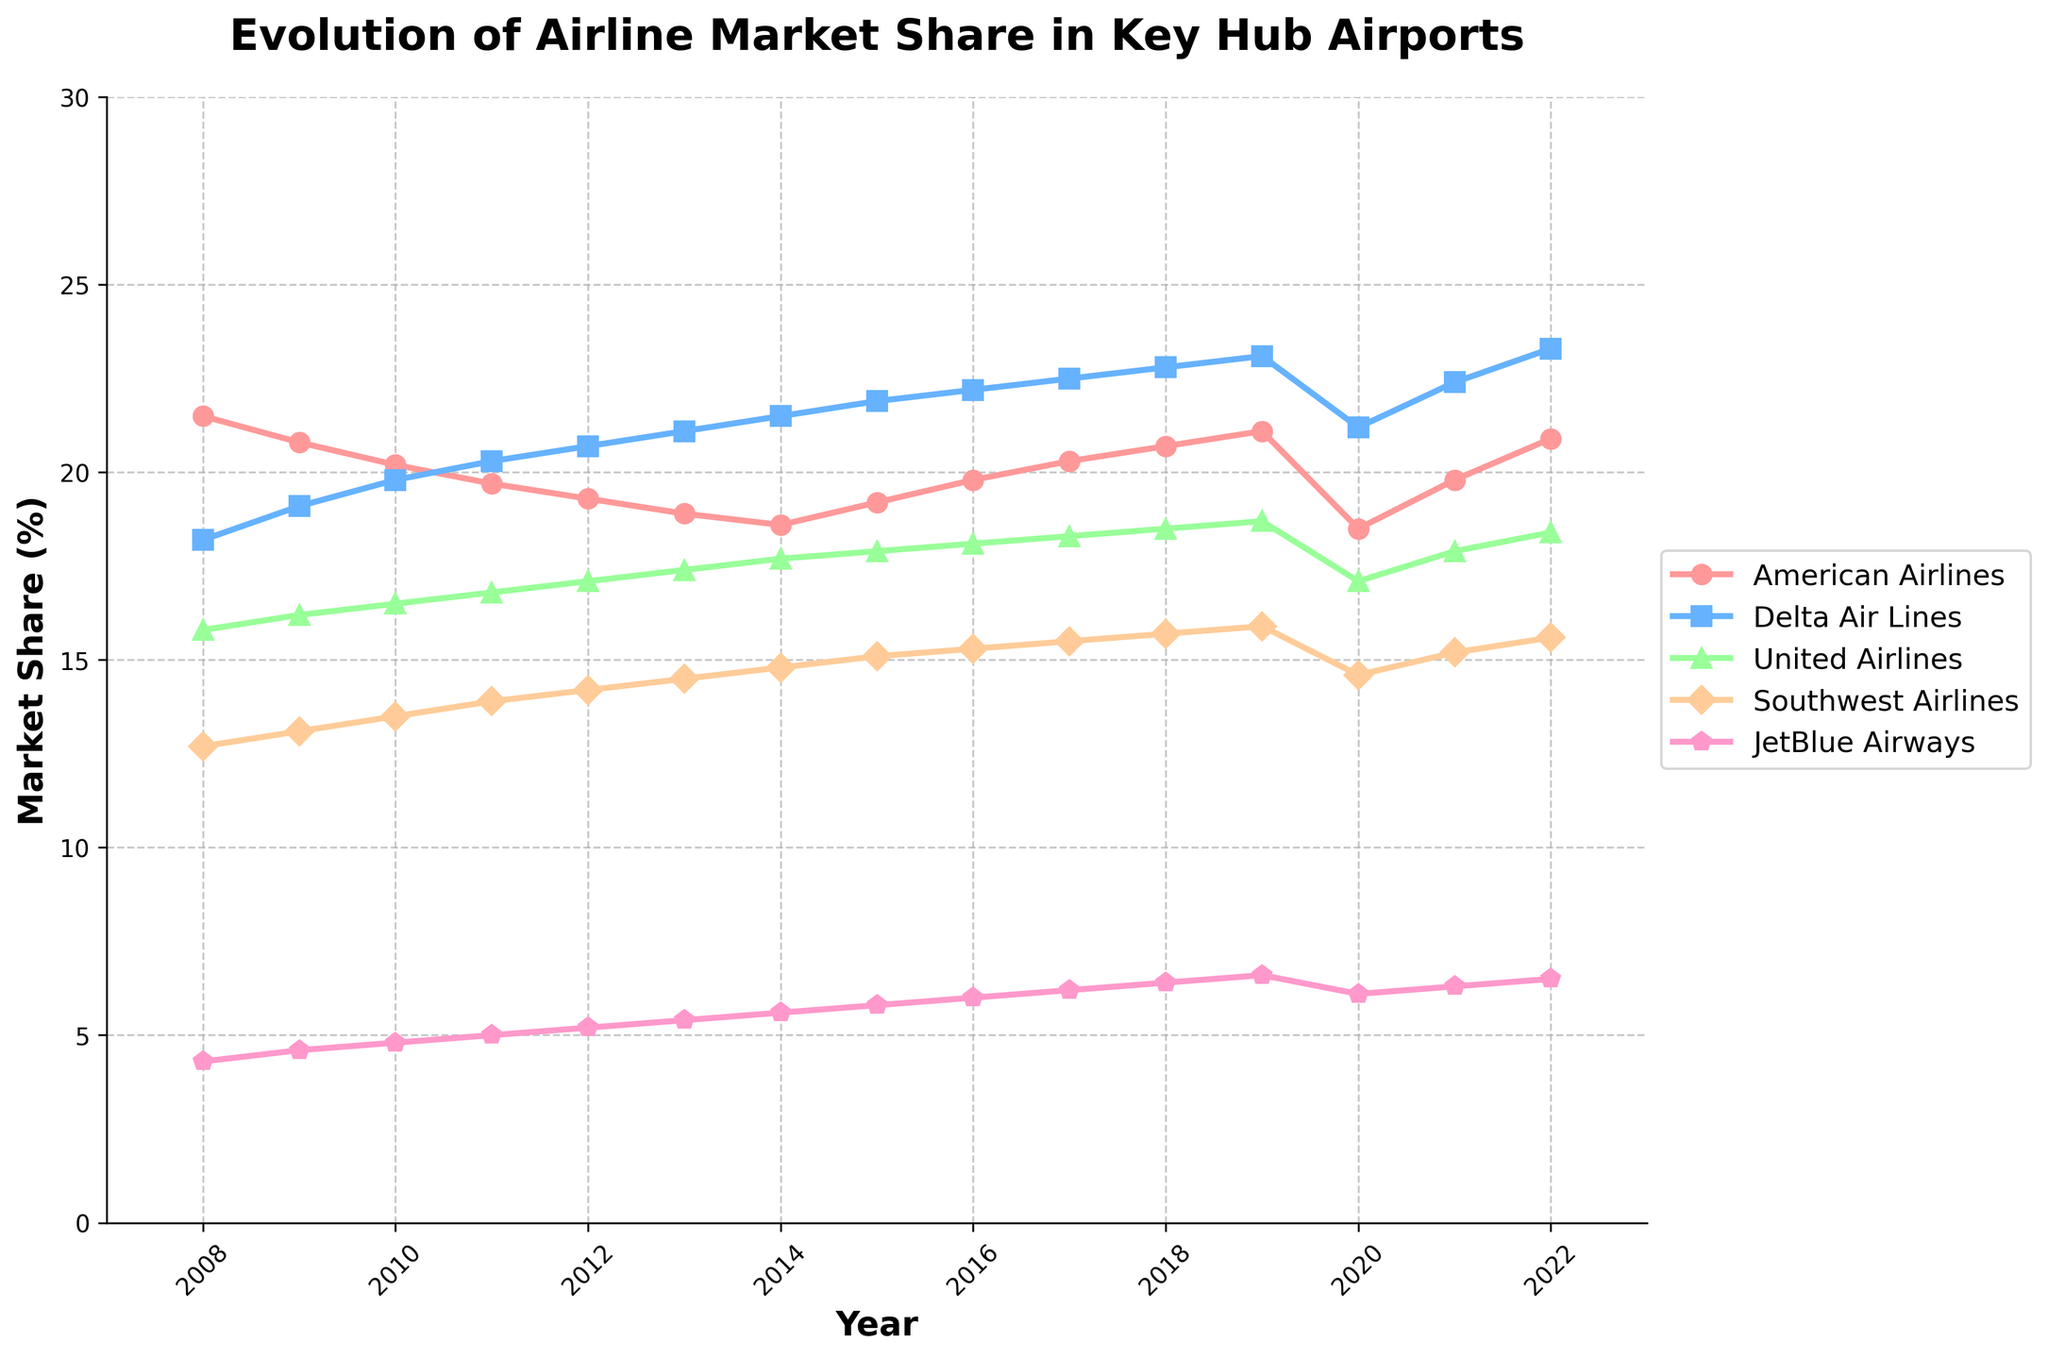What's the peak market share for Delta Air Lines, and in which year did it occur? Delta Air Lines' market share peaked at 23.3% in the year 2022. This is visible from the graph where Delta Air Lines' line reaches its highest point.
Answer: 23.3% in 2022 Which airline experienced the sharpest drop in market share in 2020 compared to 2019? By looking at the slope of the lines from 2019 to 2020, American Airlines shows the steepest decline. It dropped from 21.1% in 2019 to 18.5% in 2020.
Answer: American Airlines How did the market share of Southwest Airlines change from 2016 to 2020? Southwest Airlines' market share in 2016 was 15.3%, and it dropped to 14.6% in 2020. The change is calculated as 15.3% - 14.6% = 0.7%.
Answer: Decrease by 0.7% Which two airlines swapped positions in market share ranking between 2008 and 2020? In 2008, American Airlines has the highest market share and Delta Air Lines the second highest. By 2020, Delta Air Lines has taken the lead, and American Airlines has dropped to the second position.
Answer: American Airlines and Delta Air Lines Which airline maintained a consistent upward trend in market share over the entire 15-year period? Looking at the lines' general directions, JetBlue Airways shows a consistent upward trend without any annual decrease from 2008 to 2022.
Answer: JetBlue Airways By how many percentage points did United Airlines' market share increase or decrease from 2008 to 2022? United Airlines' market share was 15.8% in 2008 and increased to 18.4% in 2022. The change in percentage points is calculated as 18.4% - 15.8% = 2.6%.
Answer: Increased by 2.6% Which airline had the smallest total change in market share from 2008 to 2022? By comparing the changes, Southwest Airlines went from 12.7% in 2008 to 15.6% in 2022. The total change is 15.6% - 12.7% = 2.9%, which is smaller when compared with other airlines.
Answer: Southwest Airlines 